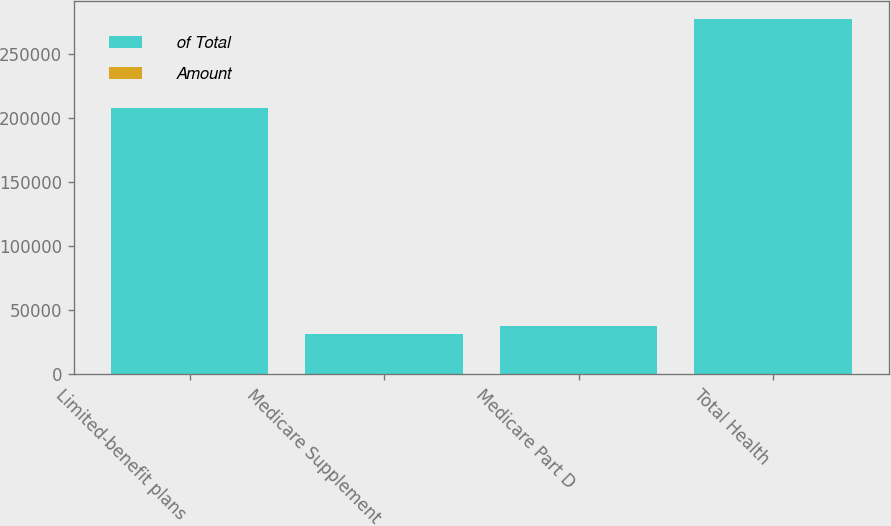<chart> <loc_0><loc_0><loc_500><loc_500><stacked_bar_chart><ecel><fcel>Limited-benefit plans<fcel>Medicare Supplement<fcel>Medicare Part D<fcel>Total Health<nl><fcel>of Total<fcel>207467<fcel>31902<fcel>37913<fcel>277282<nl><fcel>Amount<fcel>75<fcel>11<fcel>14<fcel>100<nl></chart> 